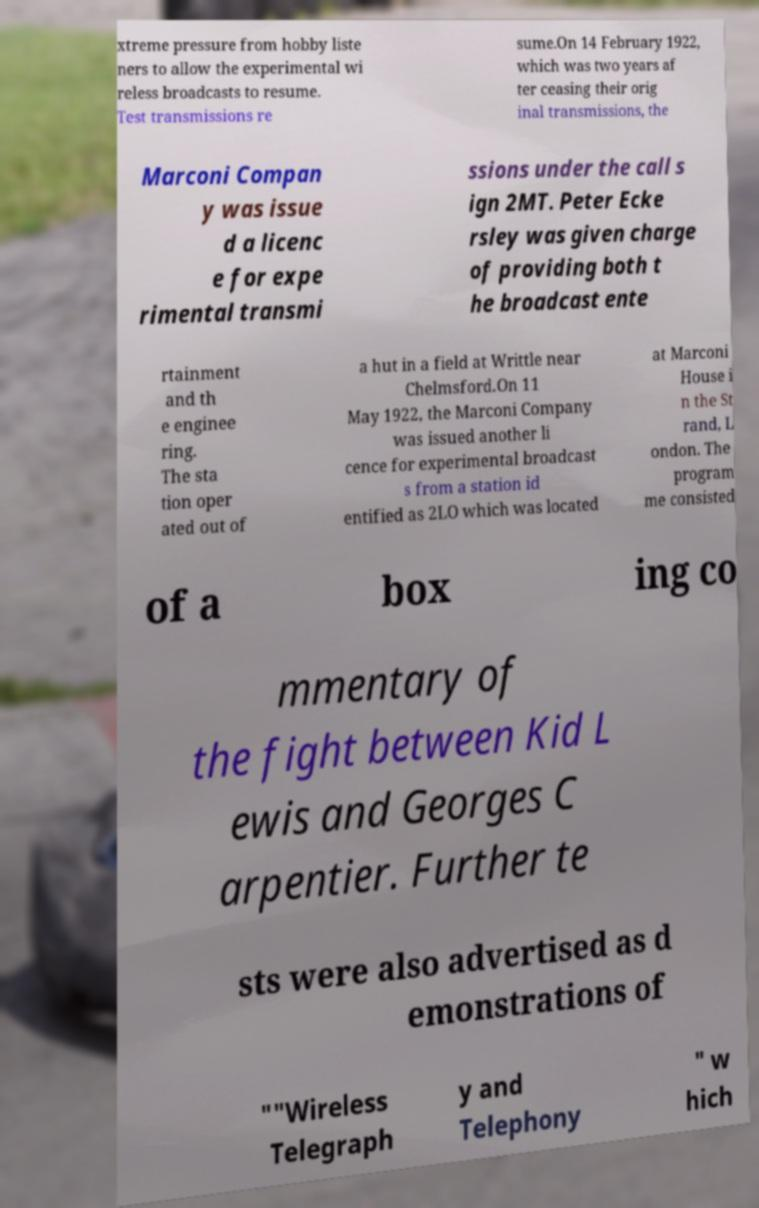Can you accurately transcribe the text from the provided image for me? xtreme pressure from hobby liste ners to allow the experimental wi reless broadcasts to resume. Test transmissions re sume.On 14 February 1922, which was two years af ter ceasing their orig inal transmissions, the Marconi Compan y was issue d a licenc e for expe rimental transmi ssions under the call s ign 2MT. Peter Ecke rsley was given charge of providing both t he broadcast ente rtainment and th e enginee ring. The sta tion oper ated out of a hut in a field at Writtle near Chelmsford.On 11 May 1922, the Marconi Company was issued another li cence for experimental broadcast s from a station id entified as 2LO which was located at Marconi House i n the St rand, L ondon. The program me consisted of a box ing co mmentary of the fight between Kid L ewis and Georges C arpentier. Further te sts were also advertised as d emonstrations of ""Wireless Telegraph y and Telephony " w hich 